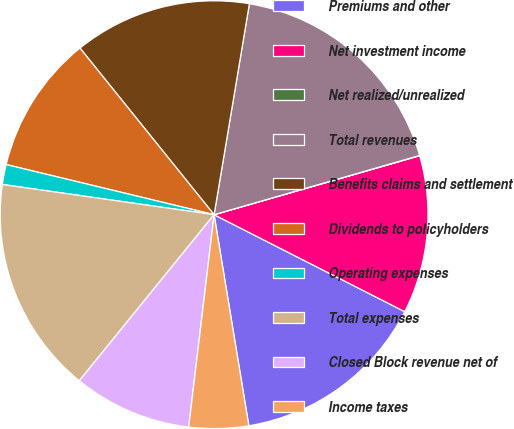<chart> <loc_0><loc_0><loc_500><loc_500><pie_chart><fcel>Premiums and other<fcel>Net investment income<fcel>Net realized/unrealized<fcel>Total revenues<fcel>Benefits claims and settlement<fcel>Dividends to policyholders<fcel>Operating expenses<fcel>Total expenses<fcel>Closed Block revenue net of<fcel>Income taxes<nl><fcel>14.92%<fcel>11.94%<fcel>0.02%<fcel>17.9%<fcel>13.43%<fcel>10.45%<fcel>1.51%<fcel>16.41%<fcel>8.96%<fcel>4.49%<nl></chart> 